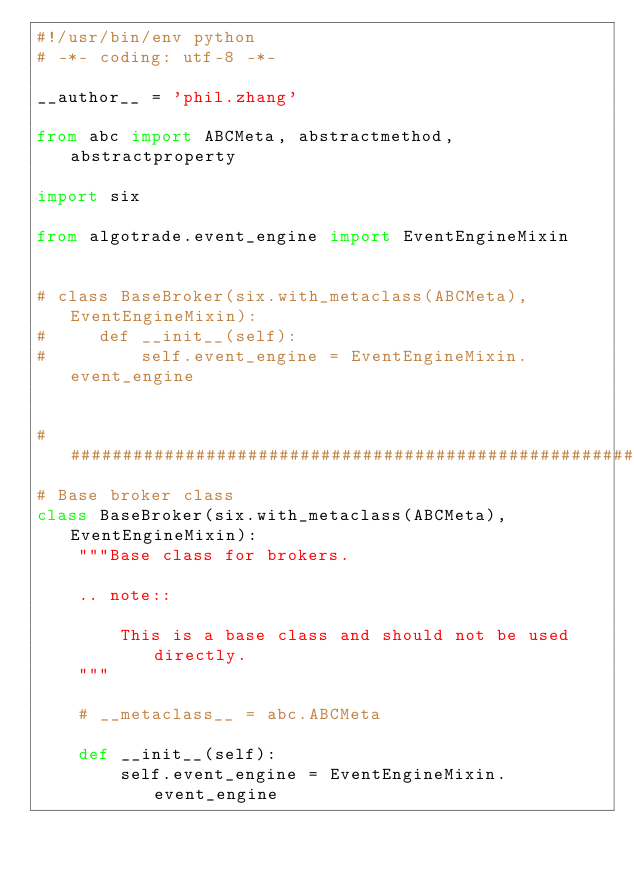<code> <loc_0><loc_0><loc_500><loc_500><_Python_>#!/usr/bin/env python
# -*- coding: utf-8 -*-

__author__ = 'phil.zhang'

from abc import ABCMeta, abstractmethod, abstractproperty

import six

from algotrade.event_engine import EventEngineMixin


# class BaseBroker(six.with_metaclass(ABCMeta), EventEngineMixin):
#     def __init__(self):
#         self.event_engine = EventEngineMixin.event_engine


######################################################################
# Base broker class
class BaseBroker(six.with_metaclass(ABCMeta), EventEngineMixin):
    """Base class for brokers.

    .. note::

        This is a base class and should not be used directly.
    """

    # __metaclass__ = abc.ABCMeta

    def __init__(self):
        self.event_engine = EventEngineMixin.event_engine
</code> 